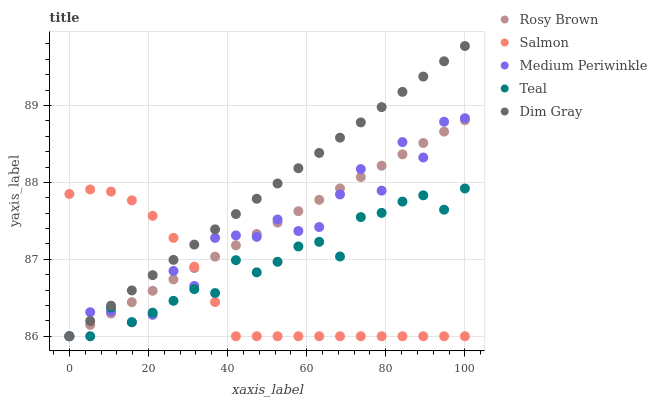Does Salmon have the minimum area under the curve?
Answer yes or no. Yes. Does Dim Gray have the maximum area under the curve?
Answer yes or no. Yes. Does Rosy Brown have the minimum area under the curve?
Answer yes or no. No. Does Rosy Brown have the maximum area under the curve?
Answer yes or no. No. Is Rosy Brown the smoothest?
Answer yes or no. Yes. Is Medium Periwinkle the roughest?
Answer yes or no. Yes. Is Dim Gray the smoothest?
Answer yes or no. No. Is Dim Gray the roughest?
Answer yes or no. No. Does Medium Periwinkle have the lowest value?
Answer yes or no. Yes. Does Dim Gray have the highest value?
Answer yes or no. Yes. Does Rosy Brown have the highest value?
Answer yes or no. No. Does Salmon intersect Dim Gray?
Answer yes or no. Yes. Is Salmon less than Dim Gray?
Answer yes or no. No. Is Salmon greater than Dim Gray?
Answer yes or no. No. 